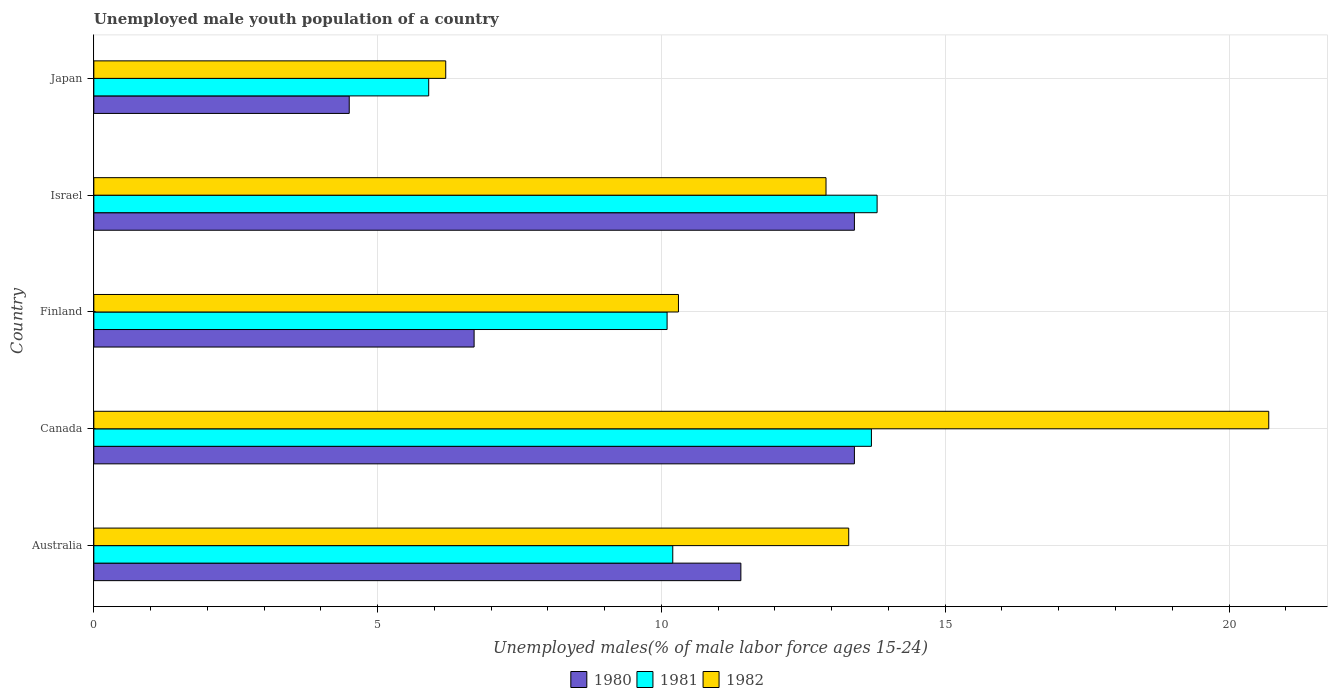How many different coloured bars are there?
Offer a very short reply. 3. Are the number of bars on each tick of the Y-axis equal?
Your answer should be compact. Yes. What is the label of the 5th group of bars from the top?
Provide a short and direct response. Australia. In how many cases, is the number of bars for a given country not equal to the number of legend labels?
Ensure brevity in your answer.  0. What is the percentage of unemployed male youth population in 1980 in Australia?
Your answer should be very brief. 11.4. Across all countries, what is the maximum percentage of unemployed male youth population in 1980?
Your answer should be compact. 13.4. In which country was the percentage of unemployed male youth population in 1981 maximum?
Your response must be concise. Israel. In which country was the percentage of unemployed male youth population in 1980 minimum?
Offer a very short reply. Japan. What is the total percentage of unemployed male youth population in 1981 in the graph?
Offer a terse response. 53.7. What is the difference between the percentage of unemployed male youth population in 1982 in Canada and that in Israel?
Keep it short and to the point. 7.8. What is the difference between the percentage of unemployed male youth population in 1980 in Israel and the percentage of unemployed male youth population in 1982 in Finland?
Keep it short and to the point. 3.1. What is the average percentage of unemployed male youth population in 1980 per country?
Your answer should be compact. 9.88. What is the difference between the percentage of unemployed male youth population in 1981 and percentage of unemployed male youth population in 1982 in Japan?
Your response must be concise. -0.3. In how many countries, is the percentage of unemployed male youth population in 1981 greater than 16 %?
Provide a short and direct response. 0. What is the ratio of the percentage of unemployed male youth population in 1982 in Australia to that in Israel?
Keep it short and to the point. 1.03. Is the percentage of unemployed male youth population in 1980 in Australia less than that in Finland?
Your answer should be very brief. No. Is the difference between the percentage of unemployed male youth population in 1981 in Australia and Israel greater than the difference between the percentage of unemployed male youth population in 1982 in Australia and Israel?
Offer a terse response. No. What is the difference between the highest and the second highest percentage of unemployed male youth population in 1981?
Provide a short and direct response. 0.1. What is the difference between the highest and the lowest percentage of unemployed male youth population in 1982?
Give a very brief answer. 14.5. In how many countries, is the percentage of unemployed male youth population in 1980 greater than the average percentage of unemployed male youth population in 1980 taken over all countries?
Offer a very short reply. 3. Is the sum of the percentage of unemployed male youth population in 1980 in Australia and Canada greater than the maximum percentage of unemployed male youth population in 1982 across all countries?
Make the answer very short. Yes. What does the 1st bar from the bottom in Finland represents?
Offer a very short reply. 1980. How many bars are there?
Offer a terse response. 15. Are all the bars in the graph horizontal?
Offer a terse response. Yes. Does the graph contain grids?
Keep it short and to the point. Yes. How many legend labels are there?
Your answer should be very brief. 3. What is the title of the graph?
Provide a short and direct response. Unemployed male youth population of a country. What is the label or title of the X-axis?
Provide a succinct answer. Unemployed males(% of male labor force ages 15-24). What is the label or title of the Y-axis?
Keep it short and to the point. Country. What is the Unemployed males(% of male labor force ages 15-24) of 1980 in Australia?
Give a very brief answer. 11.4. What is the Unemployed males(% of male labor force ages 15-24) in 1981 in Australia?
Ensure brevity in your answer.  10.2. What is the Unemployed males(% of male labor force ages 15-24) in 1982 in Australia?
Your answer should be very brief. 13.3. What is the Unemployed males(% of male labor force ages 15-24) in 1980 in Canada?
Provide a short and direct response. 13.4. What is the Unemployed males(% of male labor force ages 15-24) of 1981 in Canada?
Ensure brevity in your answer.  13.7. What is the Unemployed males(% of male labor force ages 15-24) of 1982 in Canada?
Your answer should be compact. 20.7. What is the Unemployed males(% of male labor force ages 15-24) in 1980 in Finland?
Offer a terse response. 6.7. What is the Unemployed males(% of male labor force ages 15-24) of 1981 in Finland?
Offer a very short reply. 10.1. What is the Unemployed males(% of male labor force ages 15-24) in 1982 in Finland?
Your response must be concise. 10.3. What is the Unemployed males(% of male labor force ages 15-24) of 1980 in Israel?
Your response must be concise. 13.4. What is the Unemployed males(% of male labor force ages 15-24) of 1981 in Israel?
Offer a very short reply. 13.8. What is the Unemployed males(% of male labor force ages 15-24) of 1982 in Israel?
Your answer should be very brief. 12.9. What is the Unemployed males(% of male labor force ages 15-24) of 1981 in Japan?
Your response must be concise. 5.9. What is the Unemployed males(% of male labor force ages 15-24) of 1982 in Japan?
Provide a succinct answer. 6.2. Across all countries, what is the maximum Unemployed males(% of male labor force ages 15-24) in 1980?
Ensure brevity in your answer.  13.4. Across all countries, what is the maximum Unemployed males(% of male labor force ages 15-24) of 1981?
Your answer should be very brief. 13.8. Across all countries, what is the maximum Unemployed males(% of male labor force ages 15-24) of 1982?
Provide a succinct answer. 20.7. Across all countries, what is the minimum Unemployed males(% of male labor force ages 15-24) of 1981?
Provide a short and direct response. 5.9. Across all countries, what is the minimum Unemployed males(% of male labor force ages 15-24) of 1982?
Your answer should be compact. 6.2. What is the total Unemployed males(% of male labor force ages 15-24) in 1980 in the graph?
Ensure brevity in your answer.  49.4. What is the total Unemployed males(% of male labor force ages 15-24) in 1981 in the graph?
Your answer should be very brief. 53.7. What is the total Unemployed males(% of male labor force ages 15-24) of 1982 in the graph?
Make the answer very short. 63.4. What is the difference between the Unemployed males(% of male labor force ages 15-24) of 1980 in Australia and that in Finland?
Make the answer very short. 4.7. What is the difference between the Unemployed males(% of male labor force ages 15-24) in 1982 in Australia and that in Finland?
Provide a succinct answer. 3. What is the difference between the Unemployed males(% of male labor force ages 15-24) of 1982 in Australia and that in Israel?
Your answer should be very brief. 0.4. What is the difference between the Unemployed males(% of male labor force ages 15-24) of 1980 in Australia and that in Japan?
Your answer should be compact. 6.9. What is the difference between the Unemployed males(% of male labor force ages 15-24) in 1981 in Australia and that in Japan?
Your response must be concise. 4.3. What is the difference between the Unemployed males(% of male labor force ages 15-24) in 1982 in Australia and that in Japan?
Your answer should be compact. 7.1. What is the difference between the Unemployed males(% of male labor force ages 15-24) of 1980 in Canada and that in Finland?
Your response must be concise. 6.7. What is the difference between the Unemployed males(% of male labor force ages 15-24) in 1982 in Canada and that in Finland?
Provide a succinct answer. 10.4. What is the difference between the Unemployed males(% of male labor force ages 15-24) in 1980 in Canada and that in Israel?
Ensure brevity in your answer.  0. What is the difference between the Unemployed males(% of male labor force ages 15-24) of 1981 in Canada and that in Israel?
Your answer should be very brief. -0.1. What is the difference between the Unemployed males(% of male labor force ages 15-24) of 1981 in Canada and that in Japan?
Provide a succinct answer. 7.8. What is the difference between the Unemployed males(% of male labor force ages 15-24) in 1982 in Canada and that in Japan?
Offer a terse response. 14.5. What is the difference between the Unemployed males(% of male labor force ages 15-24) in 1981 in Finland and that in Israel?
Offer a terse response. -3.7. What is the difference between the Unemployed males(% of male labor force ages 15-24) of 1982 in Finland and that in Israel?
Make the answer very short. -2.6. What is the difference between the Unemployed males(% of male labor force ages 15-24) in 1982 in Finland and that in Japan?
Give a very brief answer. 4.1. What is the difference between the Unemployed males(% of male labor force ages 15-24) in 1980 in Israel and that in Japan?
Keep it short and to the point. 8.9. What is the difference between the Unemployed males(% of male labor force ages 15-24) of 1981 in Israel and that in Japan?
Keep it short and to the point. 7.9. What is the difference between the Unemployed males(% of male labor force ages 15-24) of 1982 in Israel and that in Japan?
Your response must be concise. 6.7. What is the difference between the Unemployed males(% of male labor force ages 15-24) in 1980 in Australia and the Unemployed males(% of male labor force ages 15-24) in 1982 in Canada?
Offer a very short reply. -9.3. What is the difference between the Unemployed males(% of male labor force ages 15-24) in 1981 in Australia and the Unemployed males(% of male labor force ages 15-24) in 1982 in Canada?
Provide a short and direct response. -10.5. What is the difference between the Unemployed males(% of male labor force ages 15-24) of 1980 in Australia and the Unemployed males(% of male labor force ages 15-24) of 1981 in Finland?
Make the answer very short. 1.3. What is the difference between the Unemployed males(% of male labor force ages 15-24) in 1980 in Australia and the Unemployed males(% of male labor force ages 15-24) in 1982 in Finland?
Your response must be concise. 1.1. What is the difference between the Unemployed males(% of male labor force ages 15-24) of 1980 in Australia and the Unemployed males(% of male labor force ages 15-24) of 1981 in Israel?
Keep it short and to the point. -2.4. What is the difference between the Unemployed males(% of male labor force ages 15-24) of 1980 in Australia and the Unemployed males(% of male labor force ages 15-24) of 1982 in Israel?
Your answer should be very brief. -1.5. What is the difference between the Unemployed males(% of male labor force ages 15-24) of 1981 in Australia and the Unemployed males(% of male labor force ages 15-24) of 1982 in Japan?
Your answer should be very brief. 4. What is the difference between the Unemployed males(% of male labor force ages 15-24) in 1980 in Canada and the Unemployed males(% of male labor force ages 15-24) in 1981 in Finland?
Your answer should be very brief. 3.3. What is the difference between the Unemployed males(% of male labor force ages 15-24) in 1980 in Canada and the Unemployed males(% of male labor force ages 15-24) in 1982 in Finland?
Provide a succinct answer. 3.1. What is the difference between the Unemployed males(% of male labor force ages 15-24) in 1981 in Canada and the Unemployed males(% of male labor force ages 15-24) in 1982 in Israel?
Your response must be concise. 0.8. What is the difference between the Unemployed males(% of male labor force ages 15-24) of 1980 in Canada and the Unemployed males(% of male labor force ages 15-24) of 1981 in Japan?
Give a very brief answer. 7.5. What is the difference between the Unemployed males(% of male labor force ages 15-24) of 1980 in Canada and the Unemployed males(% of male labor force ages 15-24) of 1982 in Japan?
Offer a very short reply. 7.2. What is the difference between the Unemployed males(% of male labor force ages 15-24) of 1980 in Finland and the Unemployed males(% of male labor force ages 15-24) of 1981 in Israel?
Ensure brevity in your answer.  -7.1. What is the difference between the Unemployed males(% of male labor force ages 15-24) of 1980 in Finland and the Unemployed males(% of male labor force ages 15-24) of 1982 in Israel?
Ensure brevity in your answer.  -6.2. What is the difference between the Unemployed males(% of male labor force ages 15-24) of 1981 in Finland and the Unemployed males(% of male labor force ages 15-24) of 1982 in Japan?
Give a very brief answer. 3.9. What is the average Unemployed males(% of male labor force ages 15-24) in 1980 per country?
Your response must be concise. 9.88. What is the average Unemployed males(% of male labor force ages 15-24) in 1981 per country?
Make the answer very short. 10.74. What is the average Unemployed males(% of male labor force ages 15-24) in 1982 per country?
Your response must be concise. 12.68. What is the difference between the Unemployed males(% of male labor force ages 15-24) of 1980 and Unemployed males(% of male labor force ages 15-24) of 1981 in Australia?
Offer a terse response. 1.2. What is the difference between the Unemployed males(% of male labor force ages 15-24) of 1980 and Unemployed males(% of male labor force ages 15-24) of 1982 in Australia?
Your answer should be very brief. -1.9. What is the difference between the Unemployed males(% of male labor force ages 15-24) in 1981 and Unemployed males(% of male labor force ages 15-24) in 1982 in Australia?
Keep it short and to the point. -3.1. What is the difference between the Unemployed males(% of male labor force ages 15-24) of 1980 and Unemployed males(% of male labor force ages 15-24) of 1982 in Canada?
Keep it short and to the point. -7.3. What is the difference between the Unemployed males(% of male labor force ages 15-24) of 1980 and Unemployed males(% of male labor force ages 15-24) of 1982 in Finland?
Provide a short and direct response. -3.6. What is the difference between the Unemployed males(% of male labor force ages 15-24) of 1980 and Unemployed males(% of male labor force ages 15-24) of 1982 in Israel?
Offer a very short reply. 0.5. What is the difference between the Unemployed males(% of male labor force ages 15-24) of 1980 and Unemployed males(% of male labor force ages 15-24) of 1982 in Japan?
Ensure brevity in your answer.  -1.7. What is the difference between the Unemployed males(% of male labor force ages 15-24) of 1981 and Unemployed males(% of male labor force ages 15-24) of 1982 in Japan?
Give a very brief answer. -0.3. What is the ratio of the Unemployed males(% of male labor force ages 15-24) in 1980 in Australia to that in Canada?
Keep it short and to the point. 0.85. What is the ratio of the Unemployed males(% of male labor force ages 15-24) of 1981 in Australia to that in Canada?
Make the answer very short. 0.74. What is the ratio of the Unemployed males(% of male labor force ages 15-24) of 1982 in Australia to that in Canada?
Give a very brief answer. 0.64. What is the ratio of the Unemployed males(% of male labor force ages 15-24) in 1980 in Australia to that in Finland?
Your answer should be compact. 1.7. What is the ratio of the Unemployed males(% of male labor force ages 15-24) of 1981 in Australia to that in Finland?
Offer a very short reply. 1.01. What is the ratio of the Unemployed males(% of male labor force ages 15-24) of 1982 in Australia to that in Finland?
Ensure brevity in your answer.  1.29. What is the ratio of the Unemployed males(% of male labor force ages 15-24) in 1980 in Australia to that in Israel?
Make the answer very short. 0.85. What is the ratio of the Unemployed males(% of male labor force ages 15-24) of 1981 in Australia to that in Israel?
Your answer should be compact. 0.74. What is the ratio of the Unemployed males(% of male labor force ages 15-24) of 1982 in Australia to that in Israel?
Ensure brevity in your answer.  1.03. What is the ratio of the Unemployed males(% of male labor force ages 15-24) of 1980 in Australia to that in Japan?
Provide a short and direct response. 2.53. What is the ratio of the Unemployed males(% of male labor force ages 15-24) in 1981 in Australia to that in Japan?
Keep it short and to the point. 1.73. What is the ratio of the Unemployed males(% of male labor force ages 15-24) of 1982 in Australia to that in Japan?
Offer a terse response. 2.15. What is the ratio of the Unemployed males(% of male labor force ages 15-24) in 1980 in Canada to that in Finland?
Your answer should be compact. 2. What is the ratio of the Unemployed males(% of male labor force ages 15-24) in 1981 in Canada to that in Finland?
Keep it short and to the point. 1.36. What is the ratio of the Unemployed males(% of male labor force ages 15-24) in 1982 in Canada to that in Finland?
Ensure brevity in your answer.  2.01. What is the ratio of the Unemployed males(% of male labor force ages 15-24) in 1980 in Canada to that in Israel?
Provide a short and direct response. 1. What is the ratio of the Unemployed males(% of male labor force ages 15-24) of 1982 in Canada to that in Israel?
Provide a succinct answer. 1.6. What is the ratio of the Unemployed males(% of male labor force ages 15-24) of 1980 in Canada to that in Japan?
Provide a succinct answer. 2.98. What is the ratio of the Unemployed males(% of male labor force ages 15-24) of 1981 in Canada to that in Japan?
Your answer should be compact. 2.32. What is the ratio of the Unemployed males(% of male labor force ages 15-24) in 1982 in Canada to that in Japan?
Make the answer very short. 3.34. What is the ratio of the Unemployed males(% of male labor force ages 15-24) of 1980 in Finland to that in Israel?
Ensure brevity in your answer.  0.5. What is the ratio of the Unemployed males(% of male labor force ages 15-24) of 1981 in Finland to that in Israel?
Your response must be concise. 0.73. What is the ratio of the Unemployed males(% of male labor force ages 15-24) of 1982 in Finland to that in Israel?
Keep it short and to the point. 0.8. What is the ratio of the Unemployed males(% of male labor force ages 15-24) of 1980 in Finland to that in Japan?
Make the answer very short. 1.49. What is the ratio of the Unemployed males(% of male labor force ages 15-24) in 1981 in Finland to that in Japan?
Provide a succinct answer. 1.71. What is the ratio of the Unemployed males(% of male labor force ages 15-24) in 1982 in Finland to that in Japan?
Provide a succinct answer. 1.66. What is the ratio of the Unemployed males(% of male labor force ages 15-24) of 1980 in Israel to that in Japan?
Ensure brevity in your answer.  2.98. What is the ratio of the Unemployed males(% of male labor force ages 15-24) in 1981 in Israel to that in Japan?
Make the answer very short. 2.34. What is the ratio of the Unemployed males(% of male labor force ages 15-24) of 1982 in Israel to that in Japan?
Your answer should be compact. 2.08. What is the difference between the highest and the lowest Unemployed males(% of male labor force ages 15-24) of 1981?
Make the answer very short. 7.9. What is the difference between the highest and the lowest Unemployed males(% of male labor force ages 15-24) of 1982?
Make the answer very short. 14.5. 